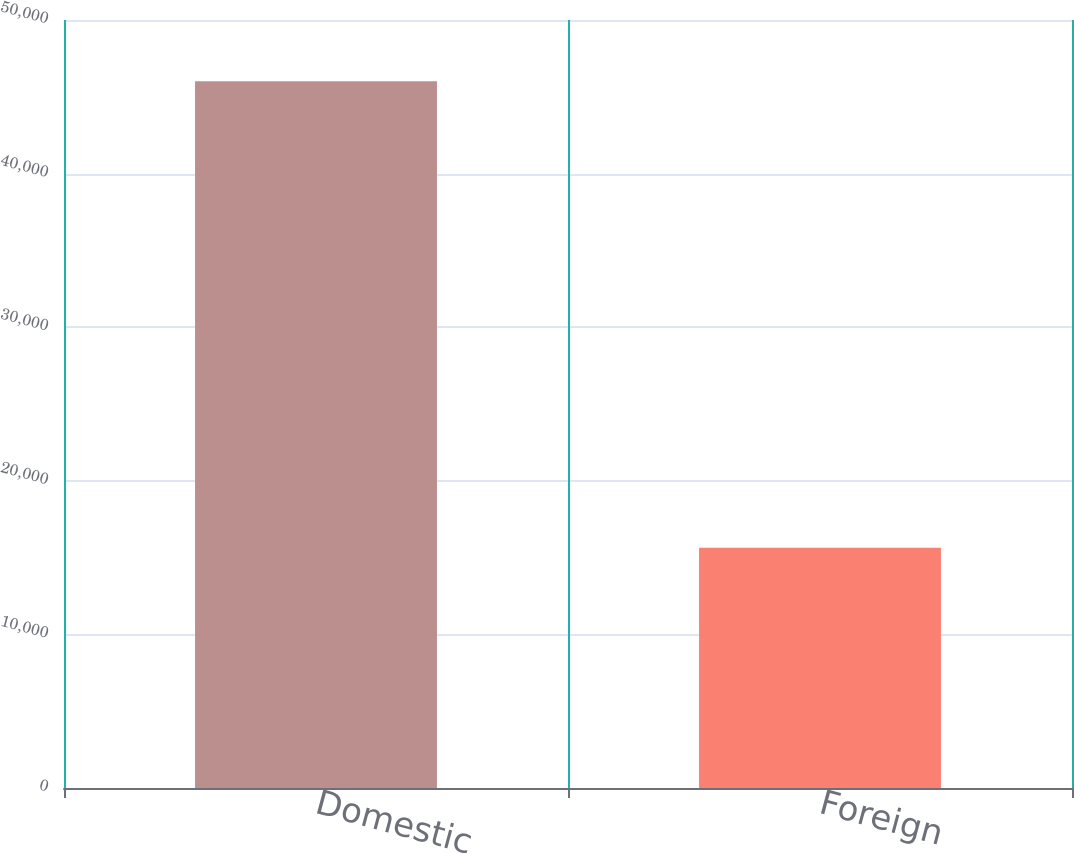Convert chart. <chart><loc_0><loc_0><loc_500><loc_500><bar_chart><fcel>Domestic<fcel>Foreign<nl><fcel>46018<fcel>15643<nl></chart> 